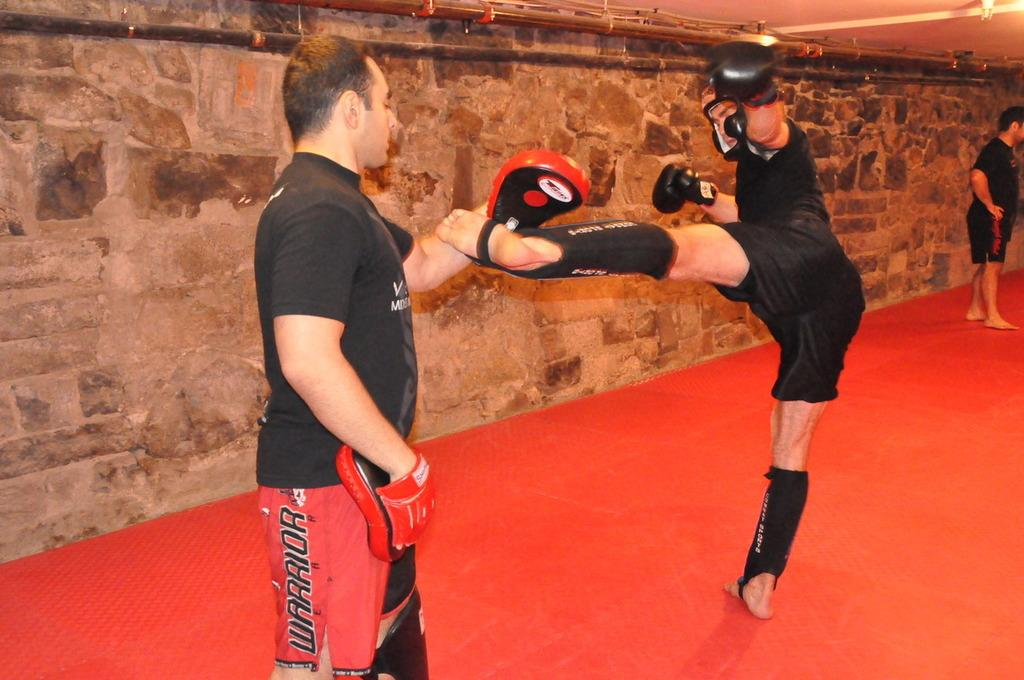What is happening in the image? There are people standing in the image. What color is the floor in the image? The floor is red in color. Can you describe the man in the middle? The man in the middle is wearing some objects. What can be seen in the background of the image? There is a wall and a ceiling in the background of the image. What type of calculator is the man in the middle using in the image? There is no calculator present in the image. What type of vest is the man in the middle wearing in the image? The provided facts do not mention a vest, so we cannot determine if the man is wearing one. Is there a spring visible in the image? There is no mention of a spring in the provided facts, so we cannot determine if one is present. 